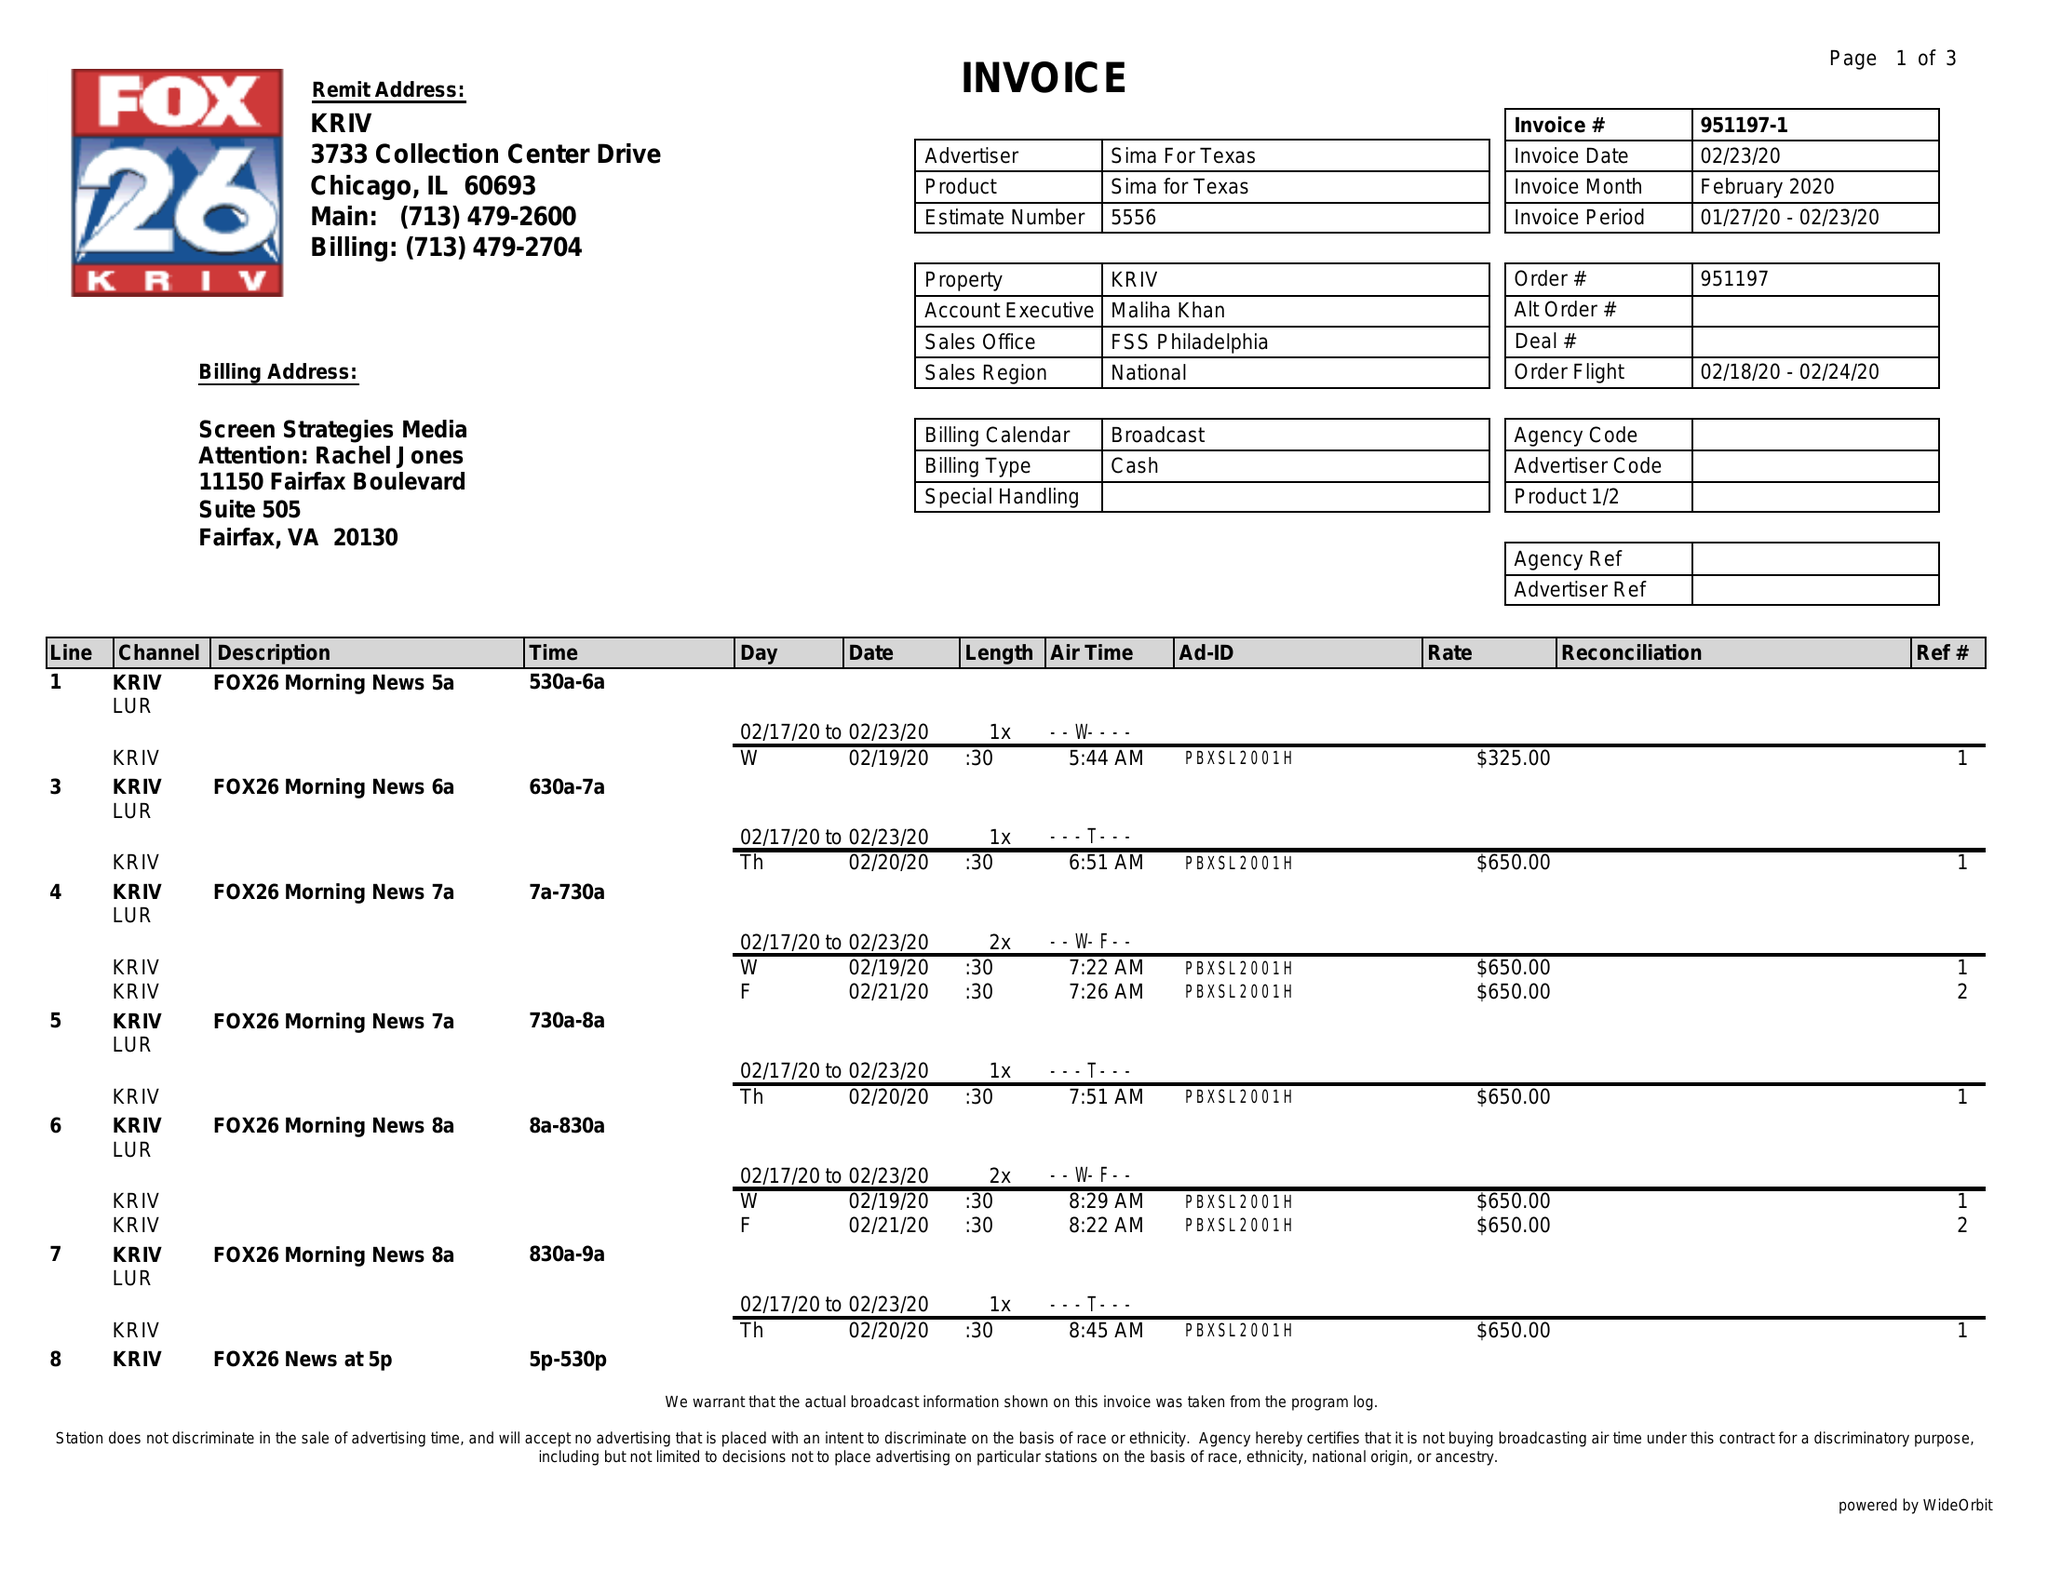What is the value for the contract_num?
Answer the question using a single word or phrase. 951197 